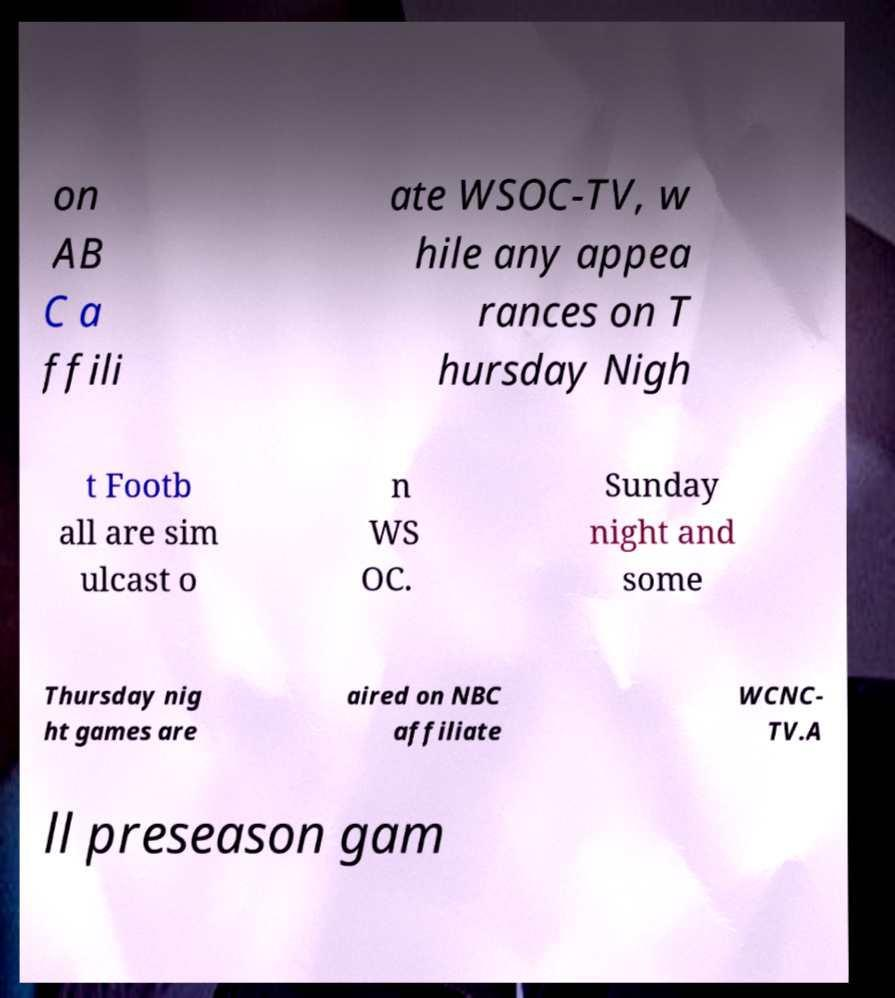Could you extract and type out the text from this image? on AB C a ffili ate WSOC-TV, w hile any appea rances on T hursday Nigh t Footb all are sim ulcast o n WS OC. Sunday night and some Thursday nig ht games are aired on NBC affiliate WCNC- TV.A ll preseason gam 